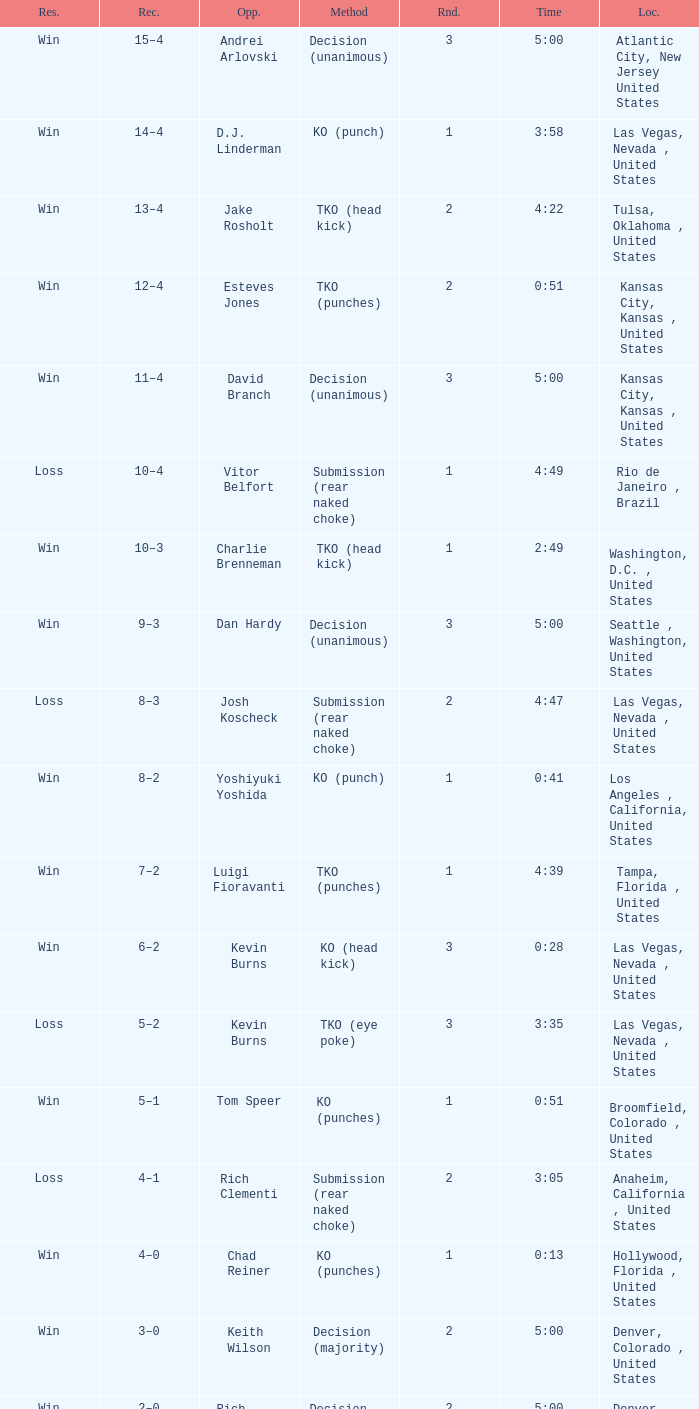What is the result for rounds under 2 against D.J. Linderman? Win. 